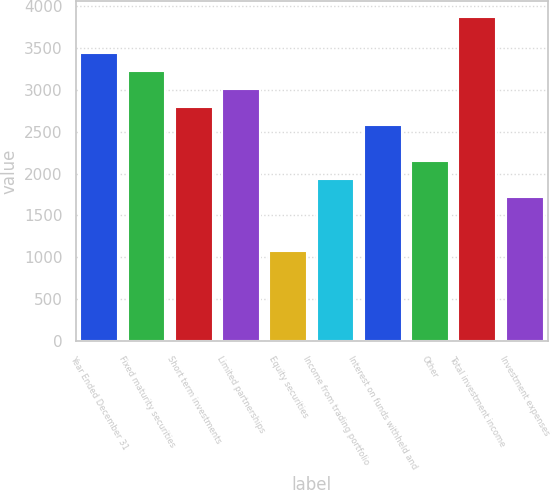Convert chart. <chart><loc_0><loc_0><loc_500><loc_500><bar_chart><fcel>Year Ended December 31<fcel>Fixed maturity securities<fcel>Short term investments<fcel>Limited partnerships<fcel>Equity securities<fcel>Income from trading portfolio<fcel>Interest on funds withheld and<fcel>Other<fcel>Total investment income<fcel>Investment expenses<nl><fcel>3439.4<fcel>3224.5<fcel>2794.7<fcel>3009.6<fcel>1075.5<fcel>1935.1<fcel>2579.8<fcel>2150<fcel>3869.2<fcel>1720.2<nl></chart> 